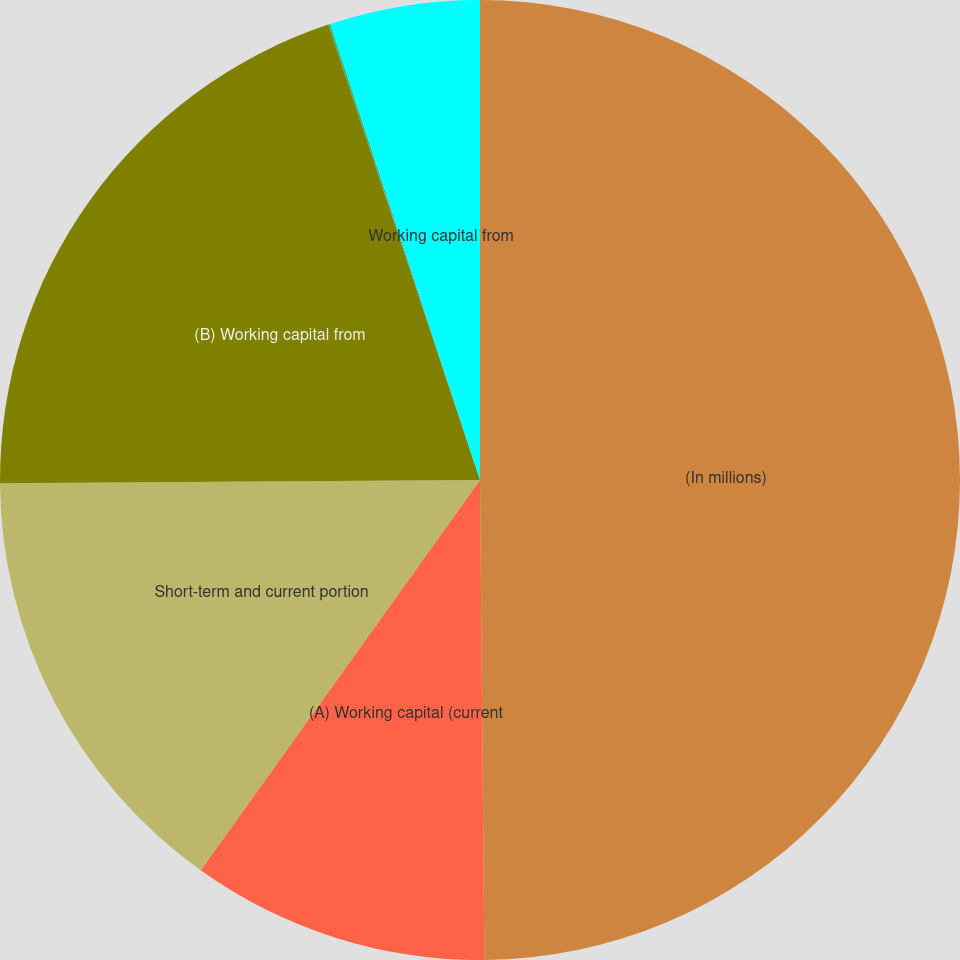Convert chart to OTSL. <chart><loc_0><loc_0><loc_500><loc_500><pie_chart><fcel>(In millions)<fcel>(A) Working capital (current<fcel>Short-term and current portion<fcel>(B) Working capital from<fcel>Working capital as a percent<fcel>Working capital from<nl><fcel>49.86%<fcel>10.03%<fcel>15.01%<fcel>19.99%<fcel>0.07%<fcel>5.05%<nl></chart> 